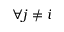Convert formula to latex. <formula><loc_0><loc_0><loc_500><loc_500>\forall j \ne i</formula> 